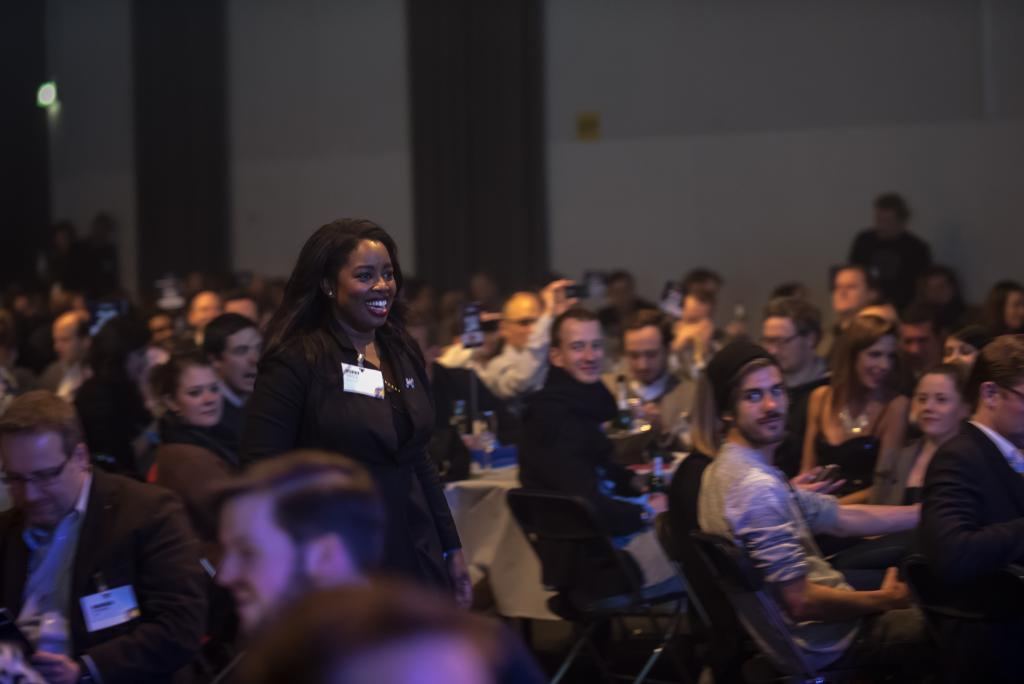What are the people in the image doing? There are many people sitting on chairs in the image. What is present on the table in the image? The table is not described in the facts, so we cannot determine what is on it. What is the background of the image? There is a wall in the image. What is providing illumination in the image? There is a light in the image. What is the woman in the image doing? There is a woman walking in the image. What type of appliance is the woman using to lead the group in the image? There is no appliance or group mentioned in the image, and the woman is simply walking. 